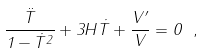Convert formula to latex. <formula><loc_0><loc_0><loc_500><loc_500>\frac { \ddot { T } } { 1 - \dot { T } ^ { 2 } } + 3 H \dot { T } + \frac { V ^ { \prime } } { V } = 0 \ ,</formula> 